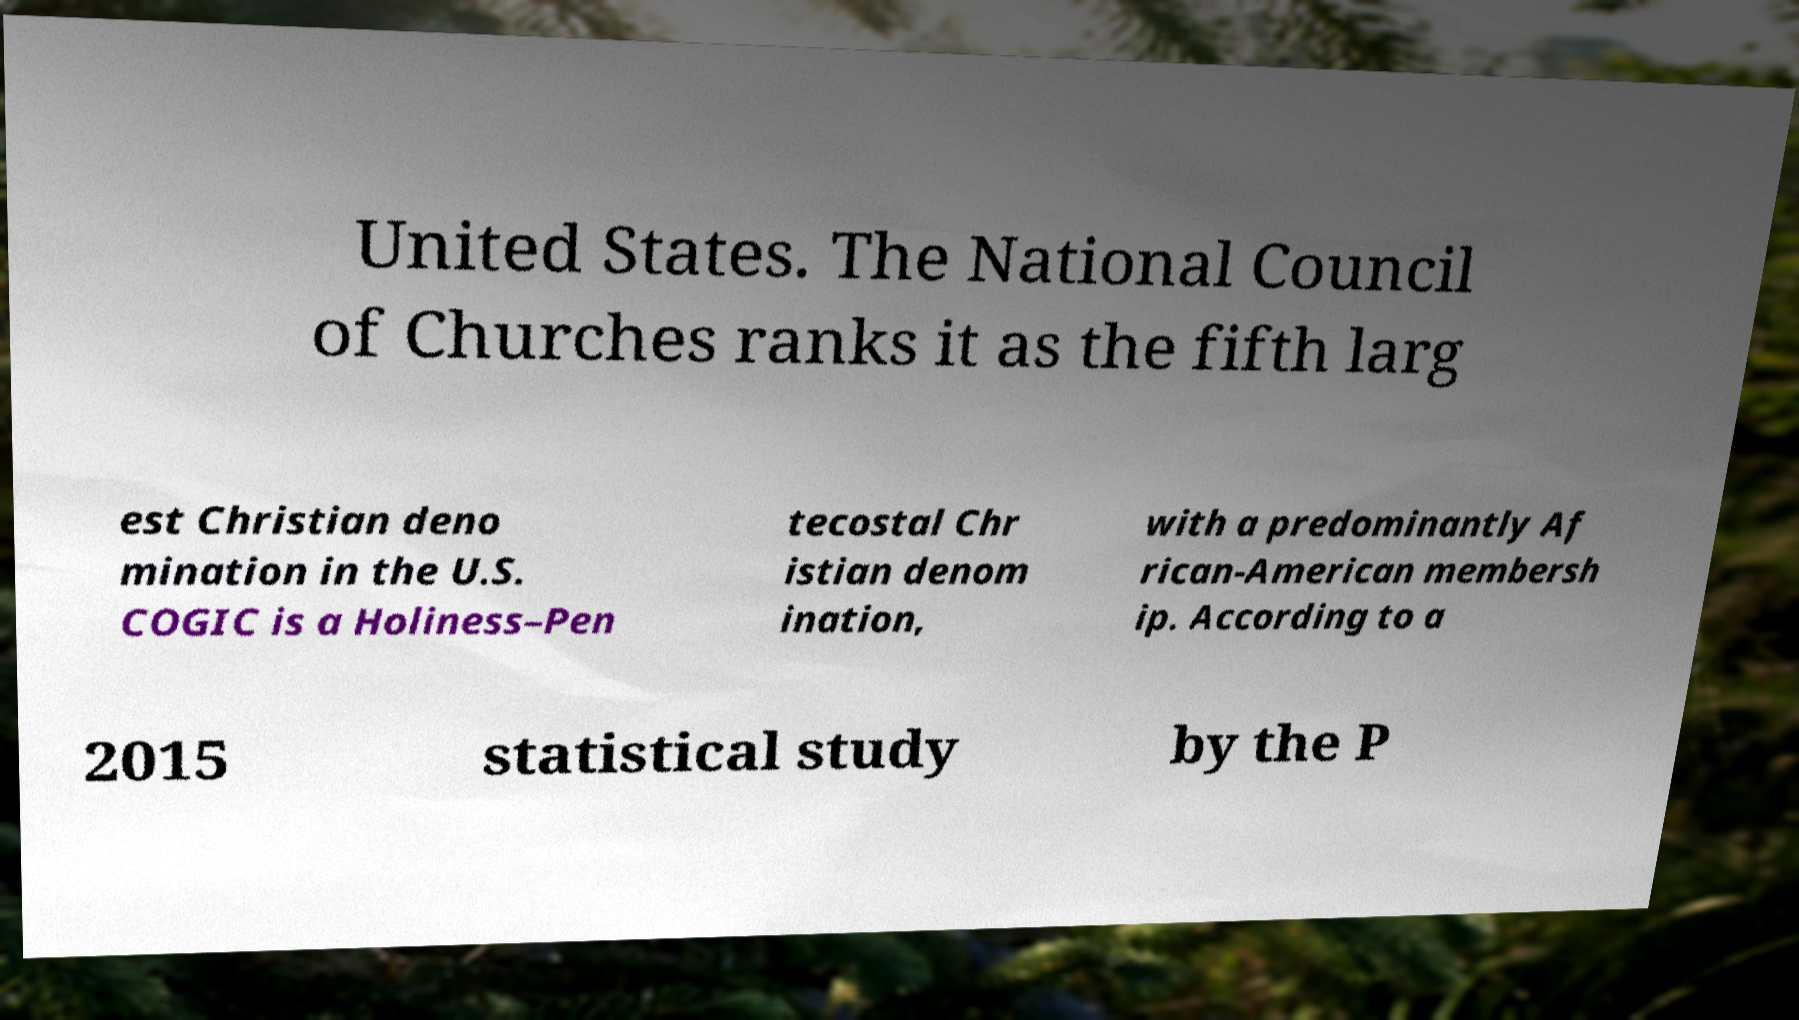Please read and relay the text visible in this image. What does it say? United States. The National Council of Churches ranks it as the fifth larg est Christian deno mination in the U.S. COGIC is a Holiness–Pen tecostal Chr istian denom ination, with a predominantly Af rican-American membersh ip. According to a 2015 statistical study by the P 